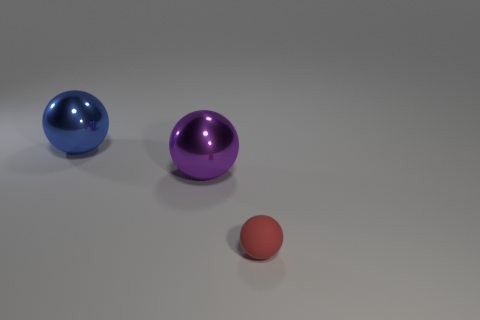What number of things are either things that are to the left of the red matte ball or objects right of the blue ball?
Offer a very short reply. 3. Do the large shiny sphere to the left of the purple metallic sphere and the rubber ball have the same color?
Ensure brevity in your answer.  No. How many other things are there of the same size as the blue ball?
Ensure brevity in your answer.  1. Do the purple thing and the large blue thing have the same material?
Your answer should be compact. Yes. There is a sphere in front of the metal ball that is right of the blue shiny ball; what is its color?
Your answer should be very brief. Red. The red thing that is the same shape as the large blue object is what size?
Give a very brief answer. Small. What number of red balls are right of the big metal sphere left of the big thing right of the blue sphere?
Offer a very short reply. 1. Are there more big purple objects than big matte cylinders?
Offer a very short reply. Yes. How many red things are there?
Ensure brevity in your answer.  1. What is the shape of the thing in front of the big shiny sphere on the right side of the metallic sphere behind the large purple metal object?
Keep it short and to the point. Sphere. 